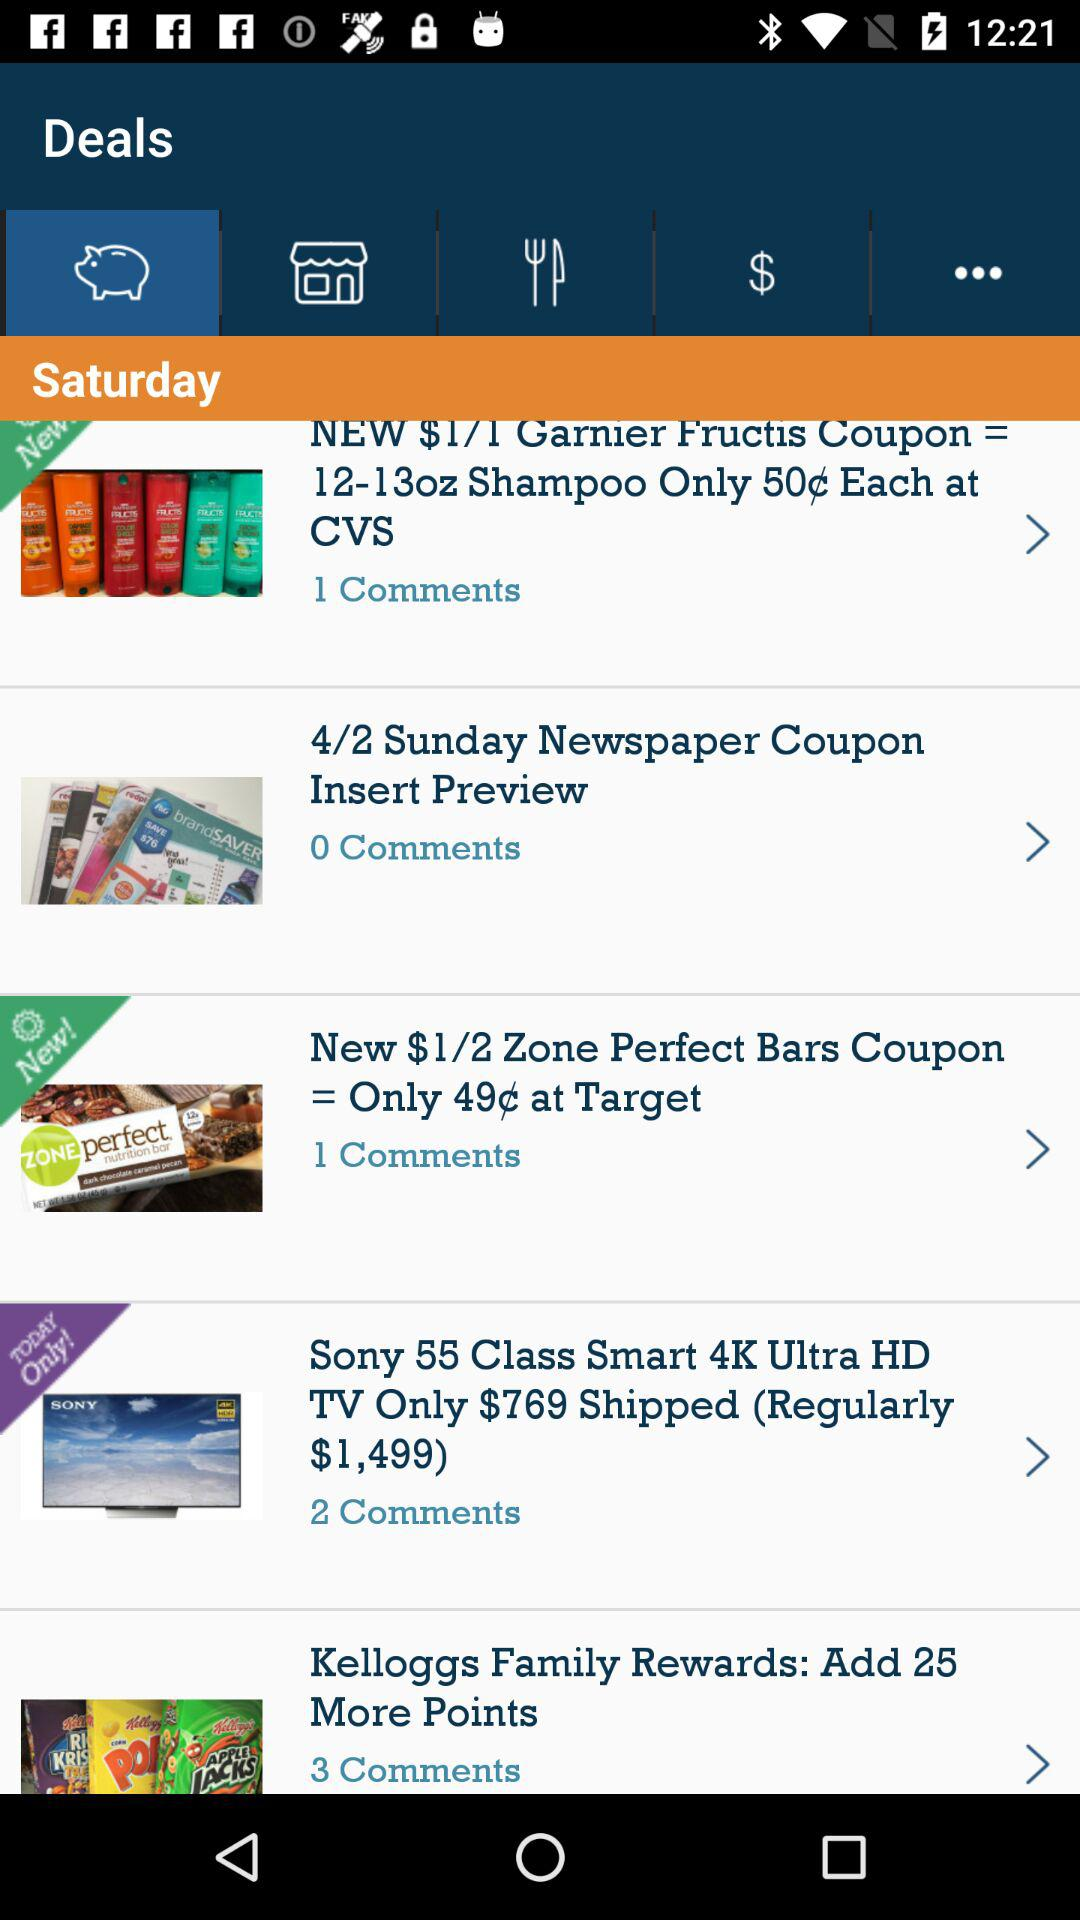How many comments are there for "4/2 Sunday Newspaper Coupon Insert Preview"? There are 0 comments. 